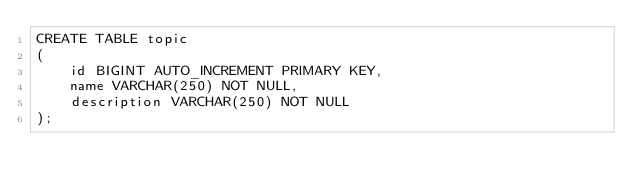Convert code to text. <code><loc_0><loc_0><loc_500><loc_500><_SQL_>CREATE TABLE topic
(
    id BIGINT AUTO_INCREMENT PRIMARY KEY,
    name VARCHAR(250) NOT NULL,
    description VARCHAR(250) NOT NULL
);</code> 